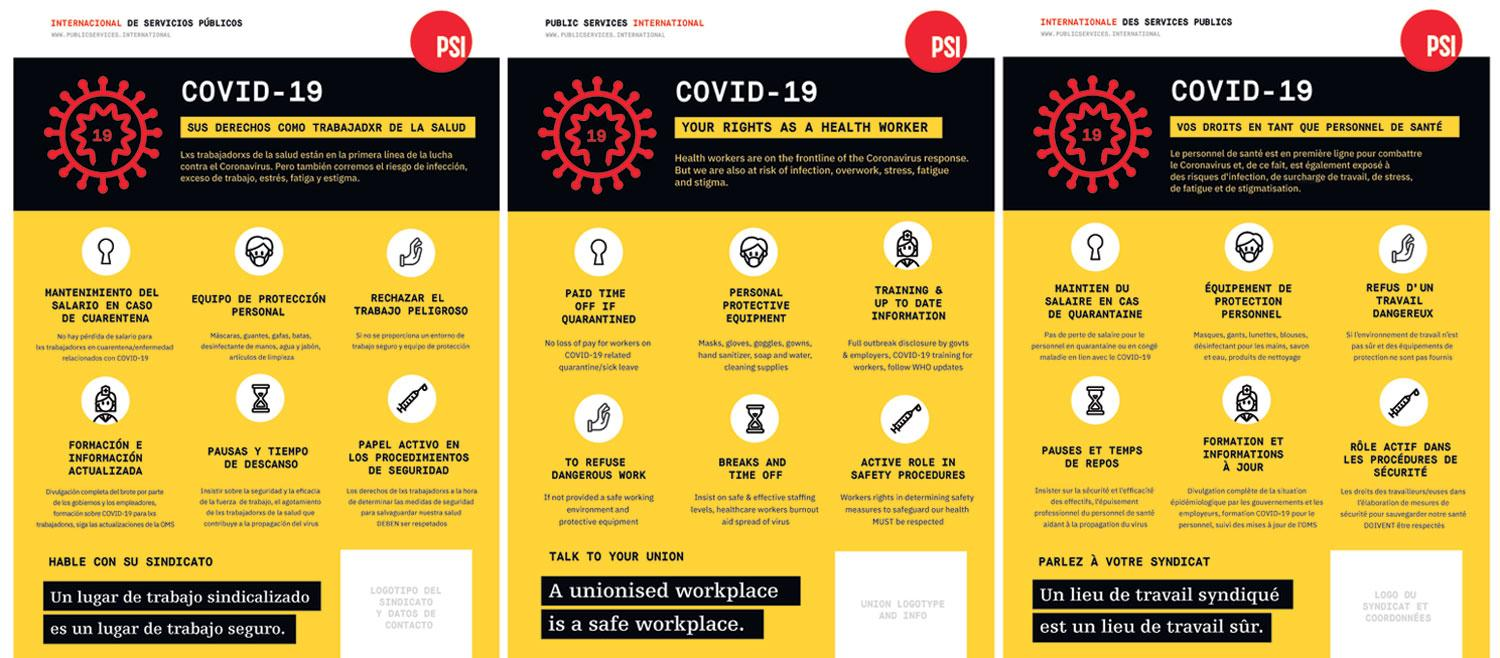Give some essential details in this illustration. Health workers are at risk of infection, overwork, stress, fatigue, and stigma, which can have a negative impact on their health and well-being. It is imperative that health workers receive proper training and up-to-date information to ensure that they are equipped to provide the best possible care to their patients. Six rights are mentioned as the rights of a health worker. The fourth right accorded to a health worker is the right to refuse dangerous work. 